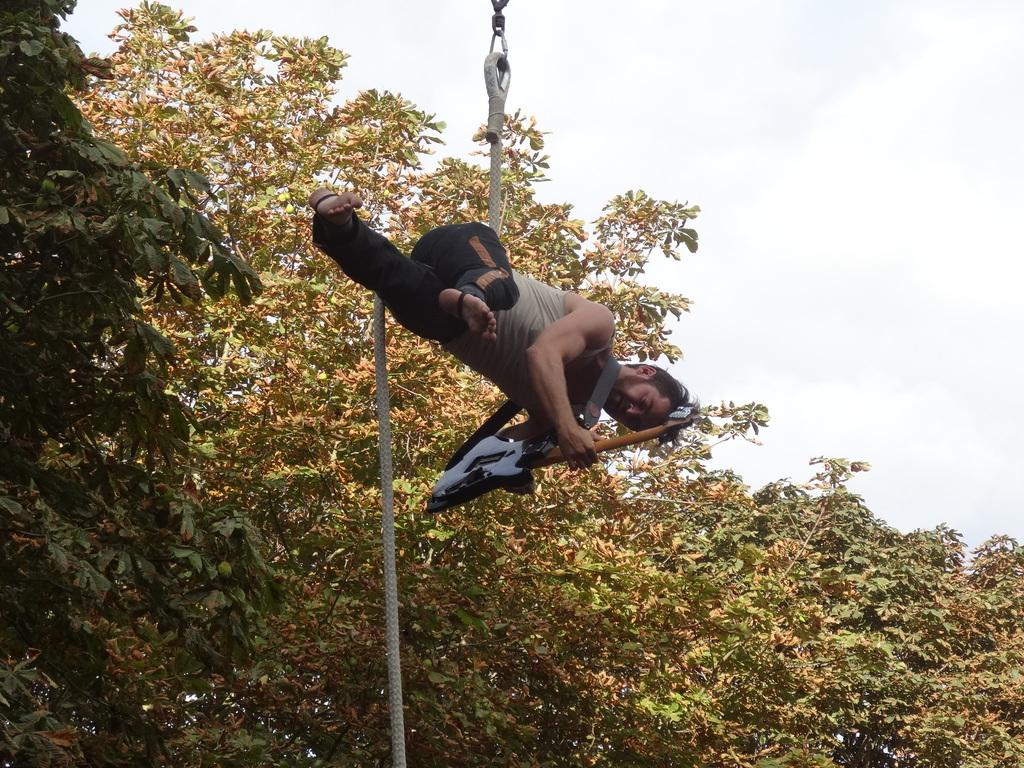What is the main subject of the image? There is a person in the image. What is the person doing in the image? The person is hanging on a rope. What object is the person holding in the image? The person is holding a guitar. What can be seen in the background of the image? There are trees visible in the background of the image. What type of protest can be seen happening in the image? There is no protest visible in the image; it features a person hanging on a rope and holding a guitar. What type of material is the person rubbing on the guitar in the image? There is no indication in the image that the person is rubbing any material on the guitar. 